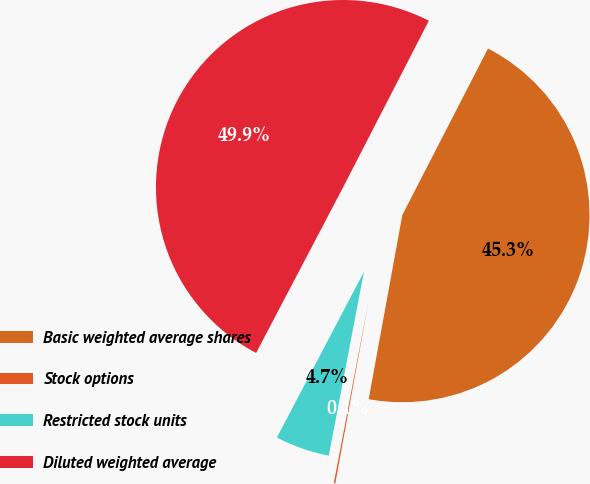Convert chart. <chart><loc_0><loc_0><loc_500><loc_500><pie_chart><fcel>Basic weighted average shares<fcel>Stock options<fcel>Restricted stock units<fcel>Diluted weighted average<nl><fcel>45.31%<fcel>0.13%<fcel>4.69%<fcel>49.87%<nl></chart> 